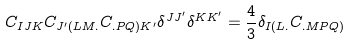Convert formula to latex. <formula><loc_0><loc_0><loc_500><loc_500>C _ { I J K } C _ { J ^ { \prime } ( L M . } C _ { . P Q ) K ^ { \prime } } \delta ^ { J J ^ { \prime } } \delta ^ { K K ^ { \prime } } = \frac { 4 } { 3 } \delta _ { I ( L . } C _ { . M P Q ) }</formula> 